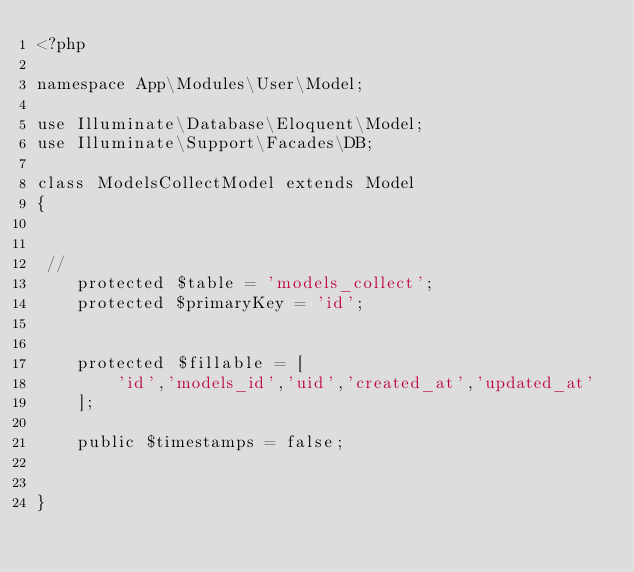Convert code to text. <code><loc_0><loc_0><loc_500><loc_500><_PHP_><?php

namespace App\Modules\User\Model;

use Illuminate\Database\Eloquent\Model;
use Illuminate\Support\Facades\DB;

class ModelsCollectModel extends Model
{


 //
    protected $table = 'models_collect';
    protected $primaryKey = 'id';
    
    
    protected $fillable = [
        'id','models_id','uid','created_at','updated_at'
    ];

    public $timestamps = false;


}</code> 